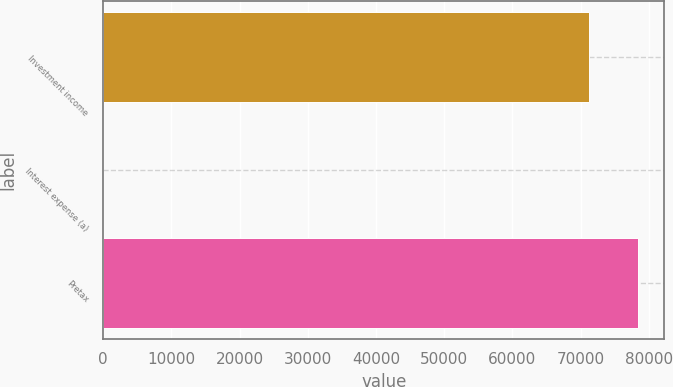<chart> <loc_0><loc_0><loc_500><loc_500><bar_chart><fcel>Investment income<fcel>Interest expense (a)<fcel>Pretax<nl><fcel>71236<fcel>4.89<fcel>78359.1<nl></chart> 